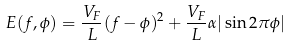<formula> <loc_0><loc_0><loc_500><loc_500>E ( f , \phi ) = \frac { V _ { F } } { L } ( f - \phi ) ^ { 2 } + \frac { V _ { F } } { L } \alpha | \sin 2 \pi \phi |</formula> 